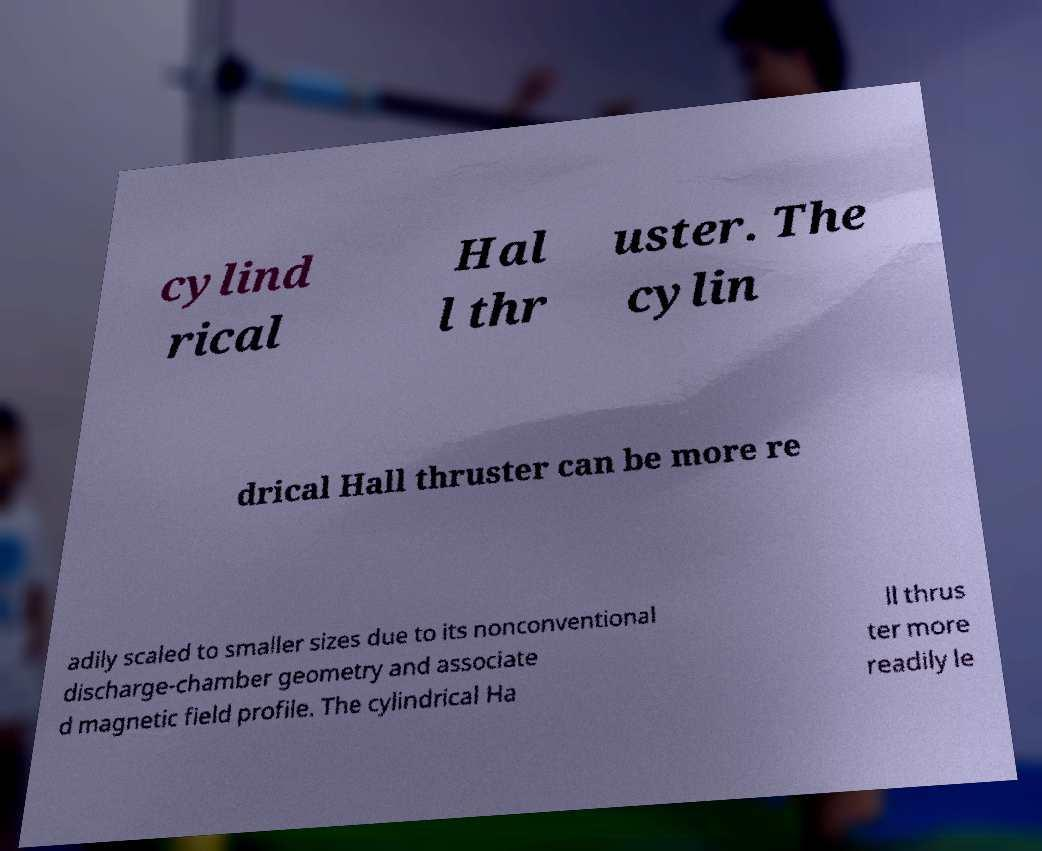Can you read and provide the text displayed in the image?This photo seems to have some interesting text. Can you extract and type it out for me? cylind rical Hal l thr uster. The cylin drical Hall thruster can be more re adily scaled to smaller sizes due to its nonconventional discharge-chamber geometry and associate d magnetic field profile. The cylindrical Ha ll thrus ter more readily le 